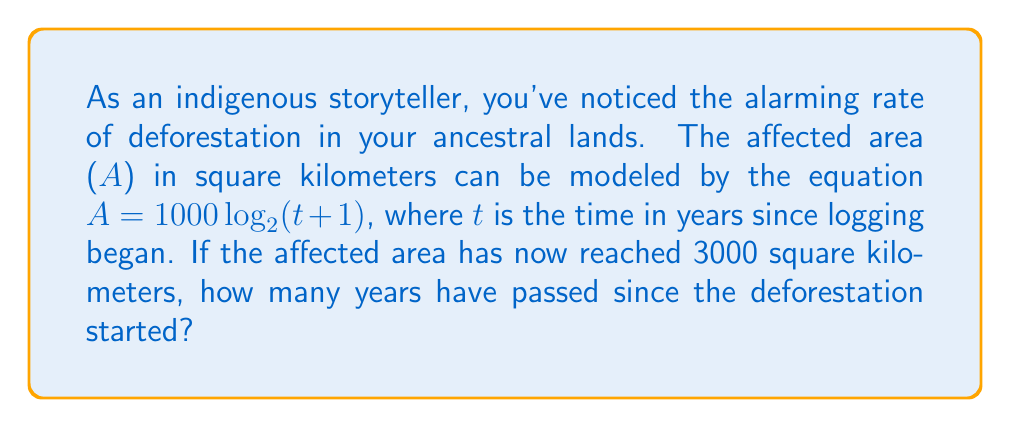What is the answer to this math problem? Let's approach this step-by-step:

1) We're given the equation $A = 1000 \log_2(t+1)$, where A is the affected area in square kilometers and t is the time in years.

2) We know that the affected area has reached 3000 square kilometers. So, we can substitute A with 3000:

   $3000 = 1000 \log_2(t+1)$

3) Divide both sides by 1000:

   $3 = \log_2(t+1)$

4) To solve for t, we need to apply the inverse function of $\log_2$, which is $2^x$:

   $2^3 = t+1$

5) Calculate $2^3$:

   $8 = t+1$

6) Subtract 1 from both sides:

   $7 = t$

Therefore, 7 years have passed since the deforestation started.
Answer: 7 years 